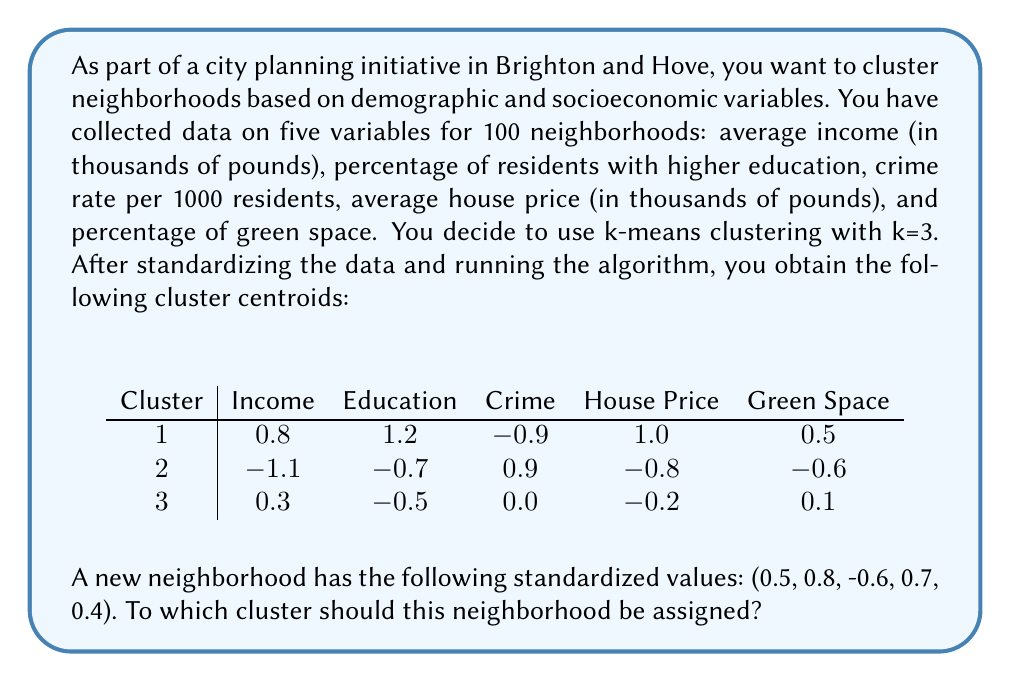Can you answer this question? To determine which cluster the new neighborhood should be assigned to, we need to calculate the Euclidean distance between the new neighborhood's standardized values and each cluster centroid. The cluster with the smallest distance will be the one to which the new neighborhood is assigned.

Let's calculate the Euclidean distance for each cluster:

1. For Cluster 1:
   $$\begin{align}
   d_1 &= \sqrt{(0.5-0.8)^2 + (0.8-1.2)^2 + (-0.6+0.9)^2 + (0.7-1.0)^2 + (0.4-0.5)^2} \\
   &= \sqrt{(-0.3)^2 + (-0.4)^2 + (0.3)^2 + (-0.3)^2 + (-0.1)^2} \\
   &= \sqrt{0.09 + 0.16 + 0.09 + 0.09 + 0.01} \\
   &= \sqrt{0.44} \\
   &\approx 0.6633
   \end{align}$$

2. For Cluster 2:
   $$\begin{align}
   d_2 &= \sqrt{(0.5+1.1)^2 + (0.8+0.7)^2 + (-0.6-0.9)^2 + (0.7+0.8)^2 + (0.4+0.6)^2} \\
   &= \sqrt{(1.6)^2 + (1.5)^2 + (-1.5)^2 + (1.5)^2 + (1.0)^2} \\
   &= \sqrt{2.56 + 2.25 + 2.25 + 2.25 + 1.00} \\
   &= \sqrt{10.31} \\
   &\approx 3.2109
   \end{align}$$

3. For Cluster 3:
   $$\begin{align}
   d_3 &= \sqrt{(0.5-0.3)^2 + (0.8+0.5)^2 + (-0.6-0.0)^2 + (0.7+0.2)^2 + (0.4-0.1)^2} \\
   &= \sqrt{(0.2)^2 + (1.3)^2 + (-0.6)^2 + (0.9)^2 + (0.3)^2} \\
   &= \sqrt{0.04 + 1.69 + 0.36 + 0.81 + 0.09} \\
   &= \sqrt{2.99} \\
   &\approx 1.7291
   \end{align}$$

The smallest distance is $d_1 \approx 0.6633$, corresponding to Cluster 1.
Answer: The new neighborhood should be assigned to Cluster 1, as it has the smallest Euclidean distance (approximately 0.6633) to the centroid of this cluster. 